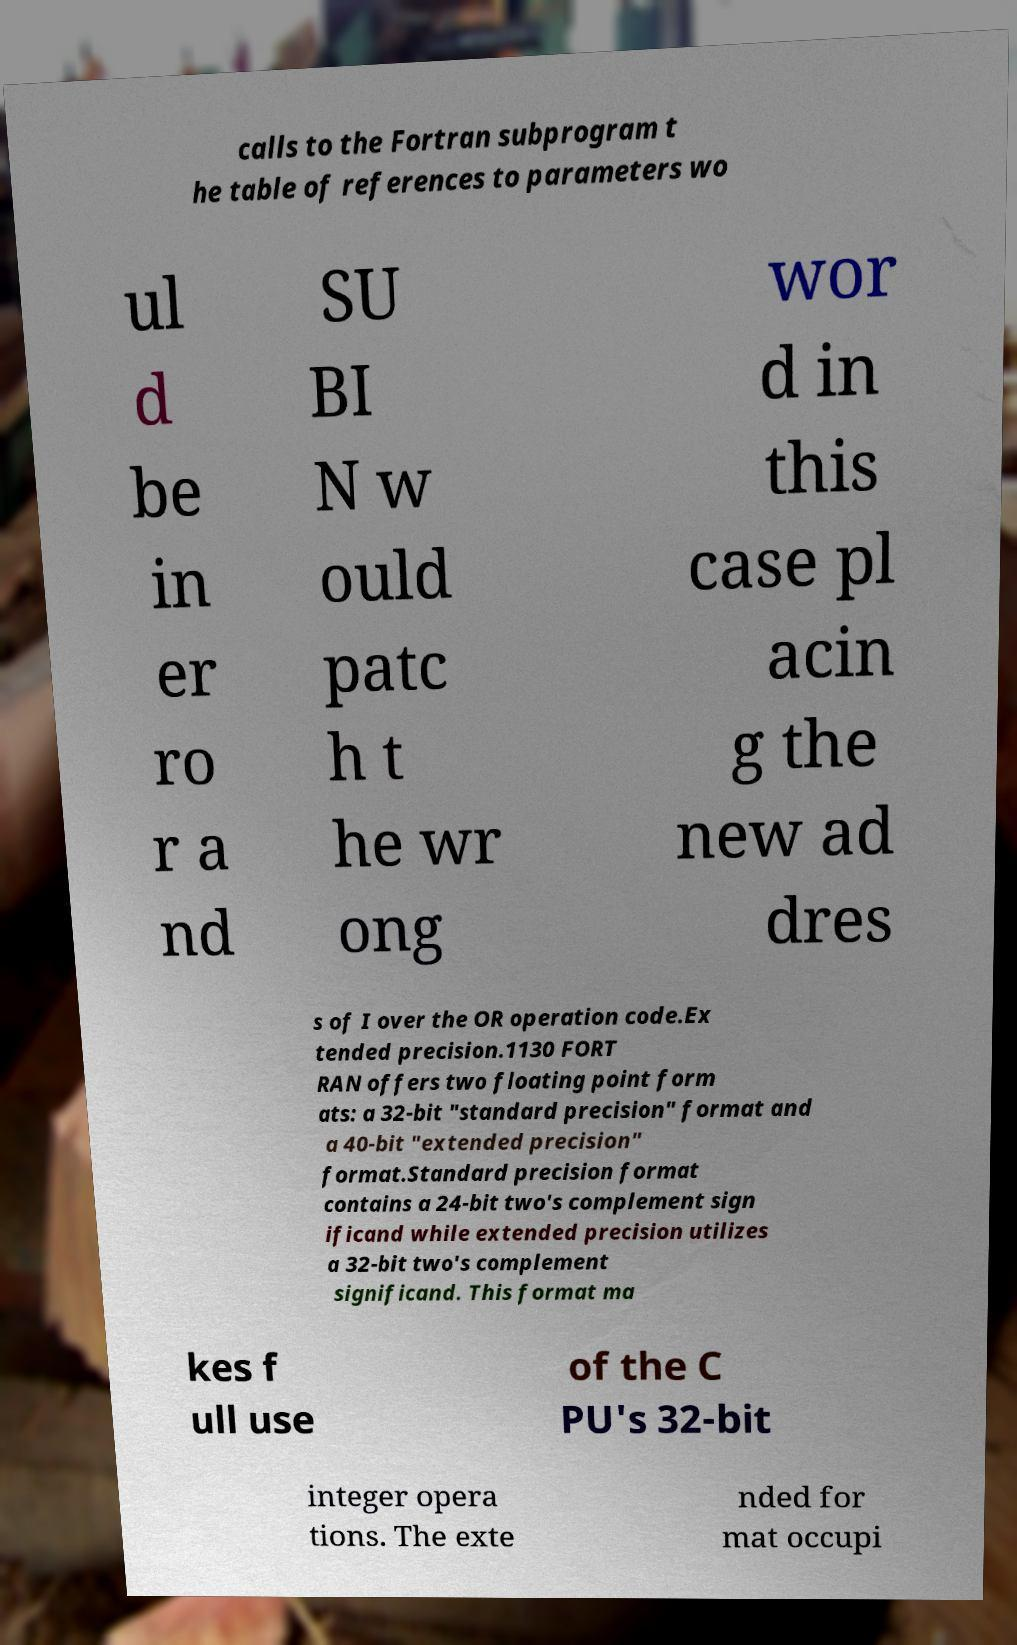Can you read and provide the text displayed in the image?This photo seems to have some interesting text. Can you extract and type it out for me? calls to the Fortran subprogram t he table of references to parameters wo ul d be in er ro r a nd SU BI N w ould patc h t he wr ong wor d in this case pl acin g the new ad dres s of I over the OR operation code.Ex tended precision.1130 FORT RAN offers two floating point form ats: a 32-bit "standard precision" format and a 40-bit "extended precision" format.Standard precision format contains a 24-bit two's complement sign ificand while extended precision utilizes a 32-bit two's complement significand. This format ma kes f ull use of the C PU's 32-bit integer opera tions. The exte nded for mat occupi 